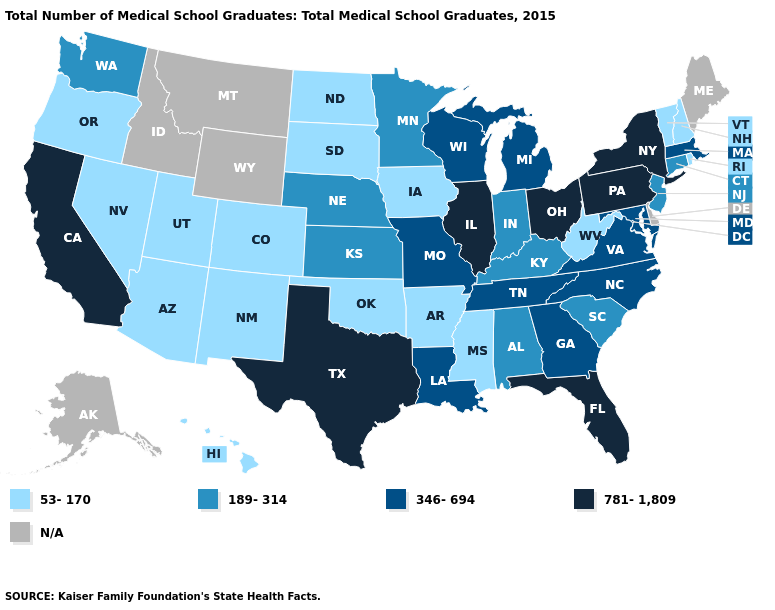Does Alabama have the lowest value in the South?
Short answer required. No. Among the states that border Massachusetts , which have the highest value?
Give a very brief answer. New York. What is the highest value in the South ?
Be succinct. 781-1,809. What is the highest value in the West ?
Write a very short answer. 781-1,809. Name the states that have a value in the range N/A?
Quick response, please. Alaska, Delaware, Idaho, Maine, Montana, Wyoming. Among the states that border Virginia , which have the highest value?
Give a very brief answer. Maryland, North Carolina, Tennessee. What is the highest value in the Northeast ?
Concise answer only. 781-1,809. What is the value of Pennsylvania?
Answer briefly. 781-1,809. What is the lowest value in the USA?
Answer briefly. 53-170. What is the value of Hawaii?
Be succinct. 53-170. What is the value of Tennessee?
Answer briefly. 346-694. 